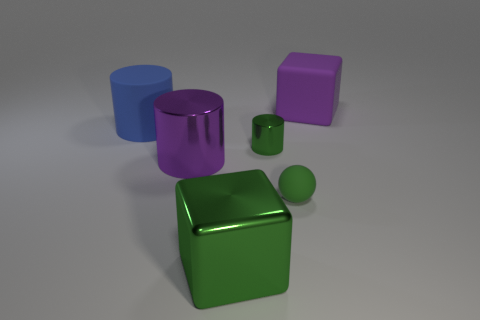There is a big shiny block; is it the same color as the metal cylinder behind the large purple metallic cylinder? yes 